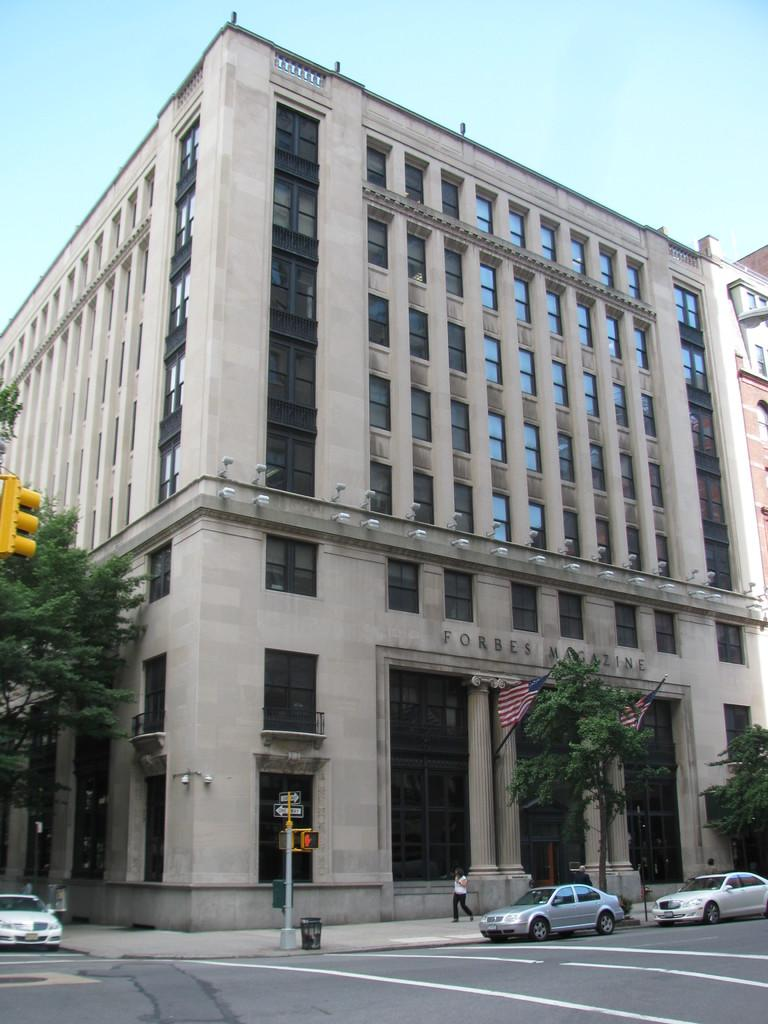What is happening on the road in the image? There are cars on a road in the image. What is the person in the image doing? There is a person walking on a footpath in the image. What can be seen in the background of the image? There are trees, buildings, and the sky visible in the background of the image. What type of baseball equipment can be seen in the image? There is no baseball equipment present in the image. Can you tell me how many partners are walking with the person in the image? There is only one person walking in the image, and no partner is visible. 